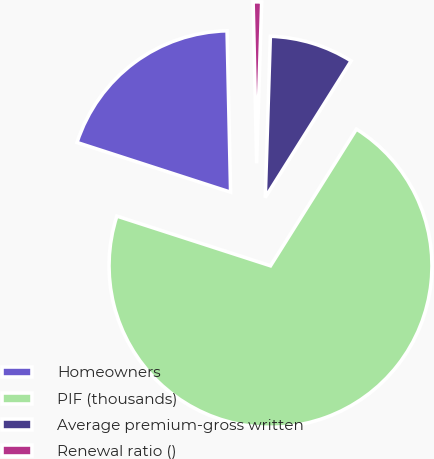Convert chart to OTSL. <chart><loc_0><loc_0><loc_500><loc_500><pie_chart><fcel>Homeowners<fcel>PIF (thousands)<fcel>Average premium-gross written<fcel>Renewal ratio ()<nl><fcel>19.67%<fcel>71.05%<fcel>8.43%<fcel>0.85%<nl></chart> 